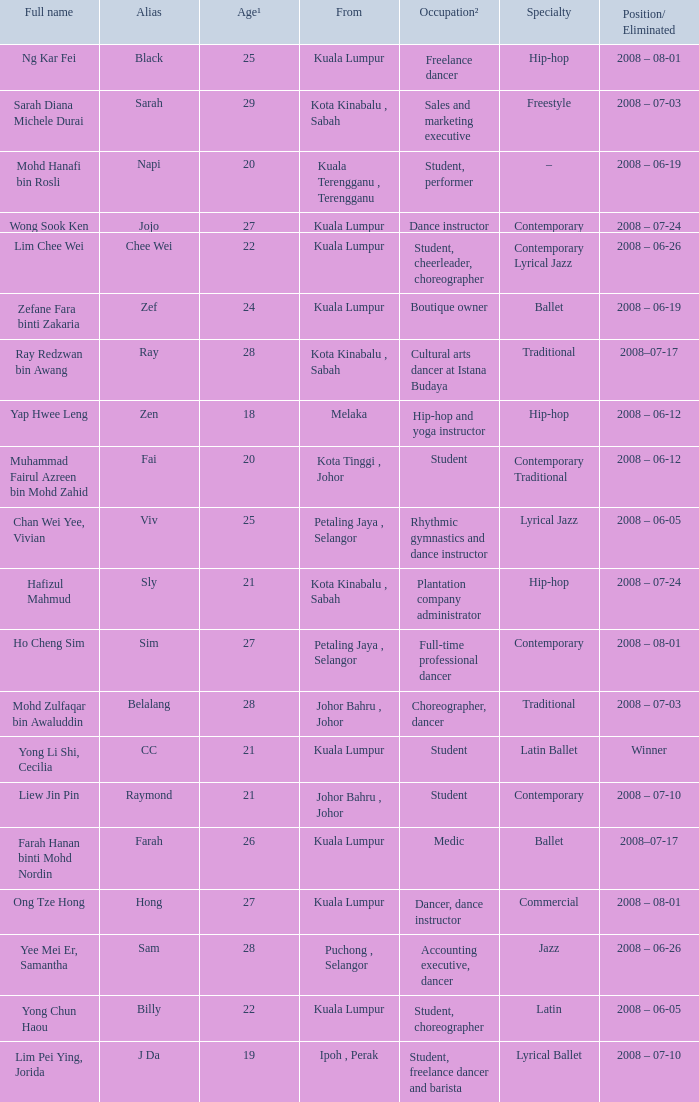If a person is 20 years old and their occupation is being a student, what would be their entire name? Muhammad Fairul Azreen bin Mohd Zahid. 